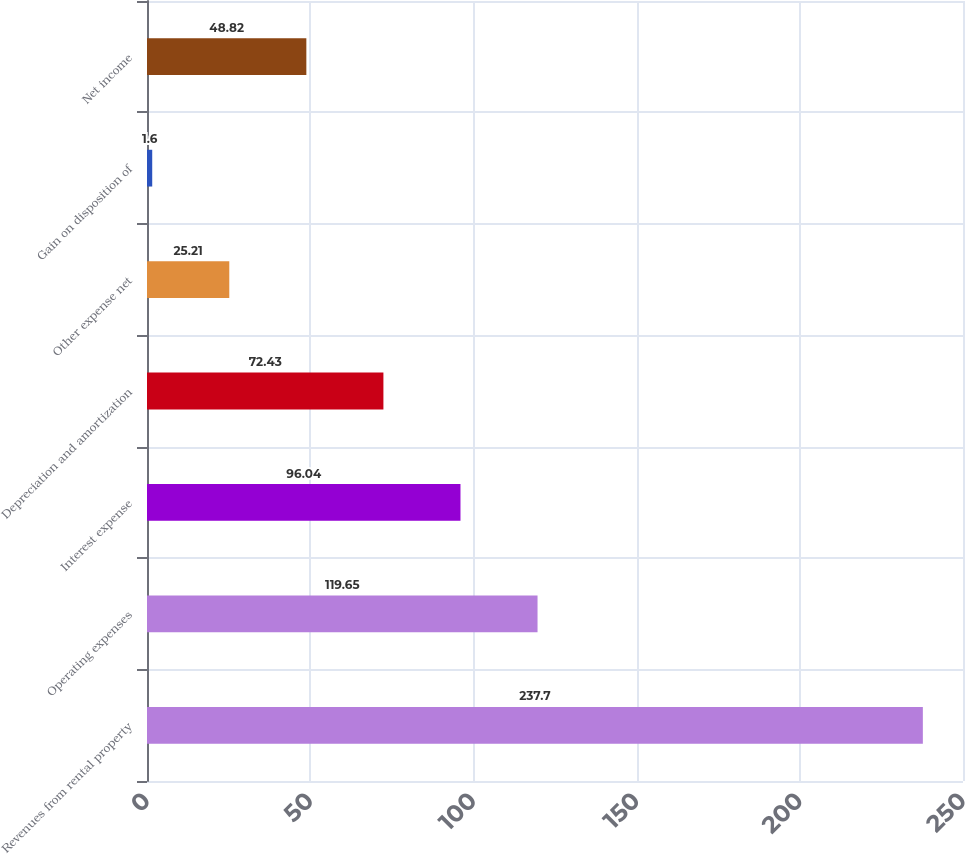<chart> <loc_0><loc_0><loc_500><loc_500><bar_chart><fcel>Revenues from rental property<fcel>Operating expenses<fcel>Interest expense<fcel>Depreciation and amortization<fcel>Other expense net<fcel>Gain on disposition of<fcel>Net income<nl><fcel>237.7<fcel>119.65<fcel>96.04<fcel>72.43<fcel>25.21<fcel>1.6<fcel>48.82<nl></chart> 